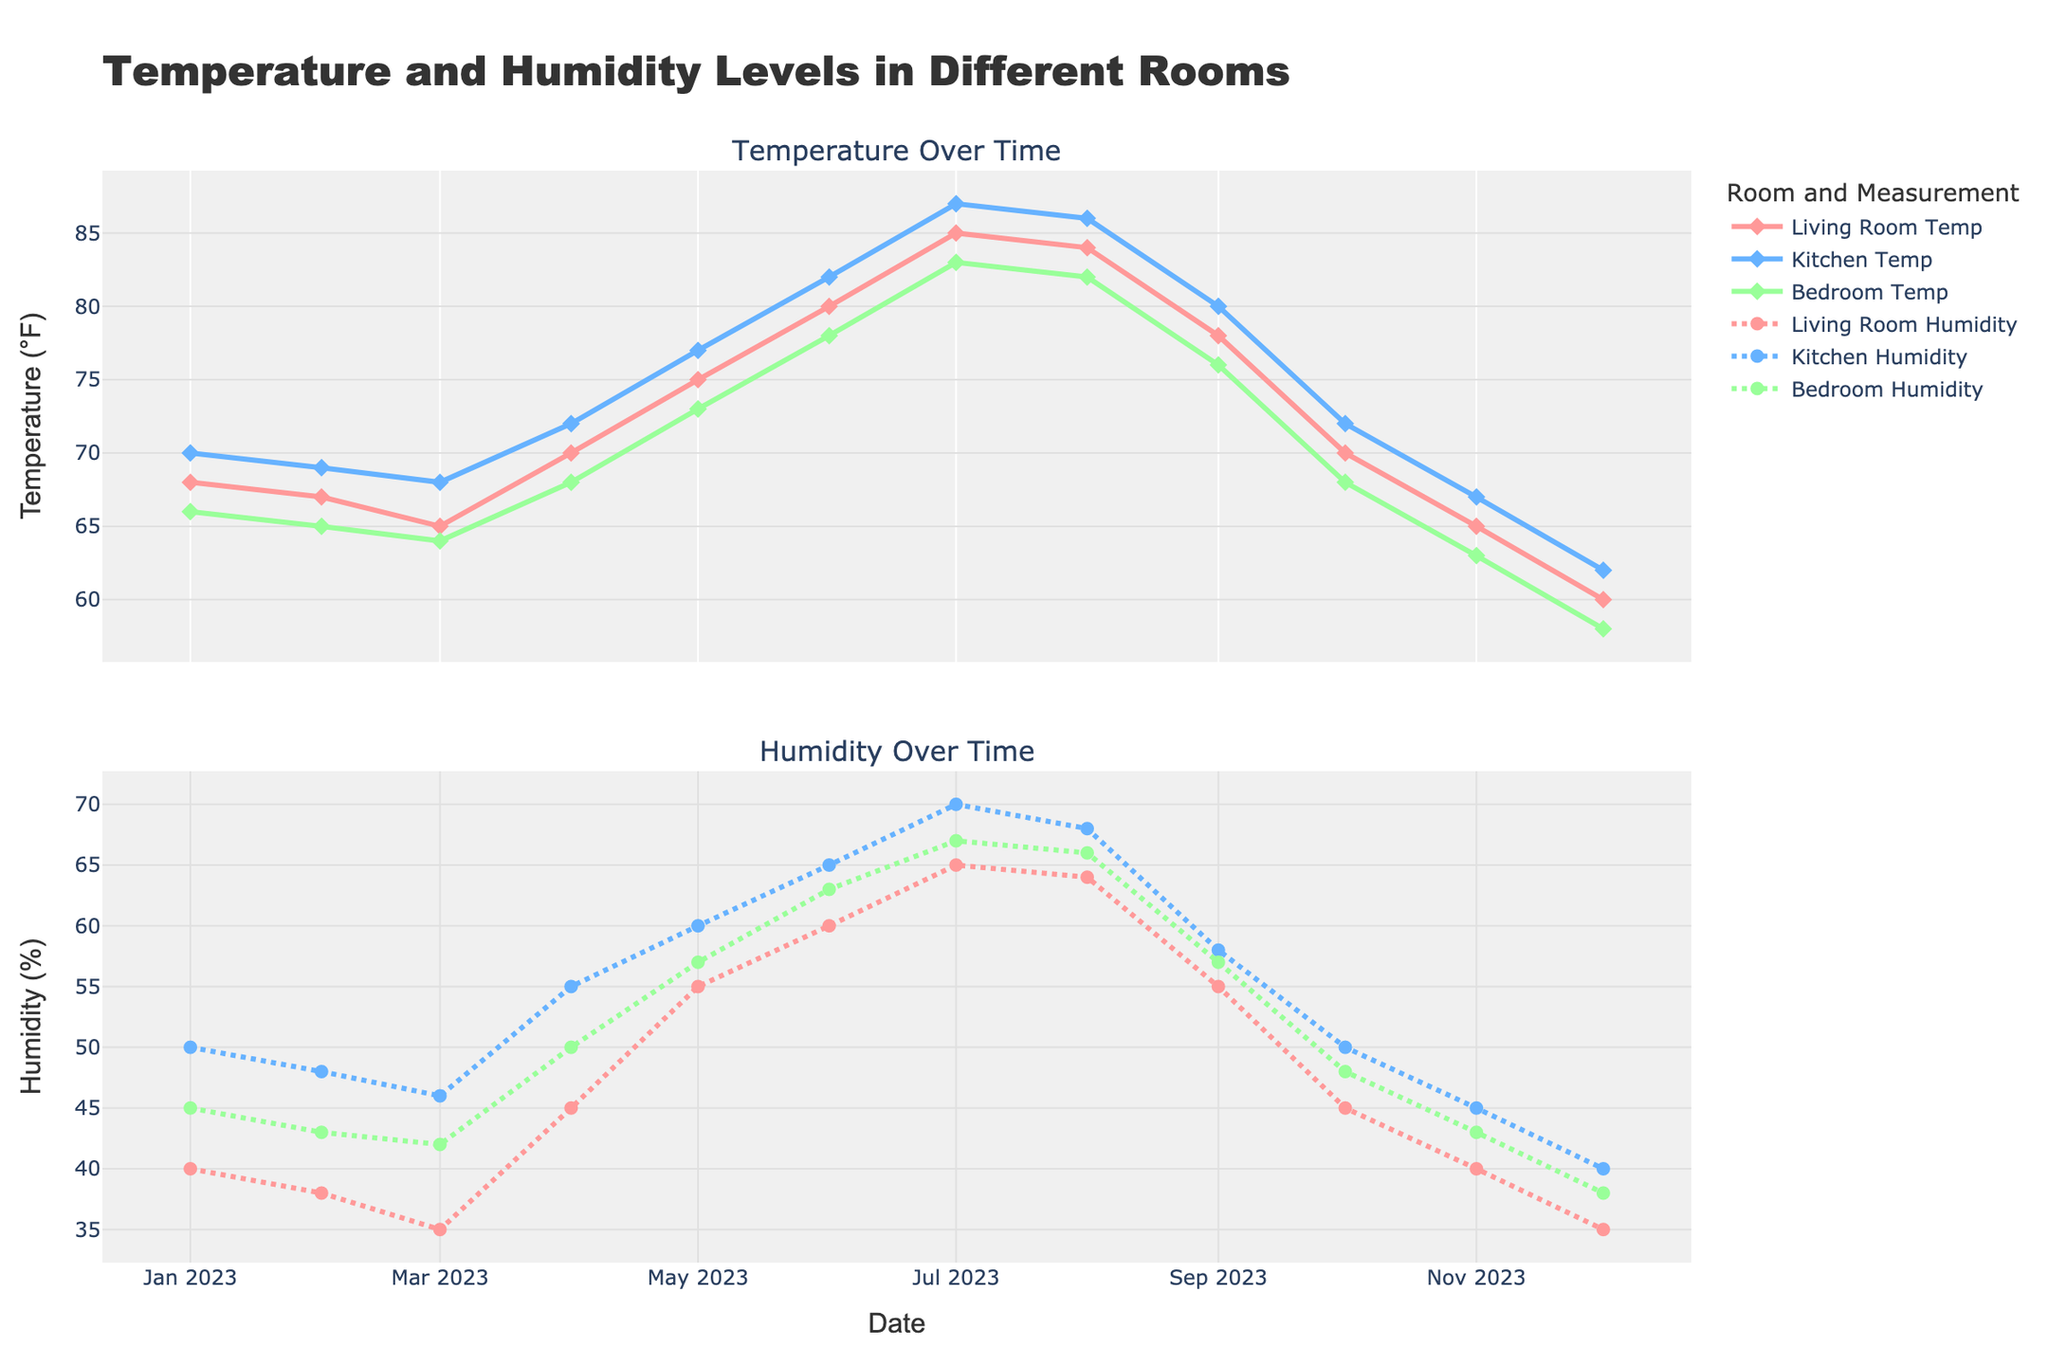What is the title of the figure? The title of the figure is generally displayed at the top of the visual information. From the layout description, the title is "Temperature and Humidity Levels in Different Rooms."
Answer: Temperature and Humidity Levels in Different Rooms Which room has the highest temperature in July? To find the highest temperature in July, locate the data points for July and compare the temperatures for the Living Room, Kitchen, and Bedroom. The Kitchen shows the highest temperature, which is 87°F.
Answer: Kitchen In which month does the Living Room have the lowest humidity and what is the value? Look at the humidity levels for the Living Room across all months. The lowest humidity is in December at 35%.
Answer: December, 35% Compare the temperature trends in the Living Room and the Bedroom. Which room shows a higher increase in temperature from January to July? Measure the increase in temperature from January (Living Room: 68°F, Bedroom: 66°F) to July (Living Room: 85°F, Bedroom: 83°F). Calculate the differences: 85 - 68 = 17°F for the Living Room and 83 - 66 = 17°F for the Bedroom. Both rooms show the same increase.
Answer: Both rooms show an equal increase What is the average humidity level in the Kitchen during the summer months (June, July, and August)? Identify the humidity levels in the Kitchen for June (65%), July (70%), and August (68%), then calculate the average: (65 + 70 + 68) / 3 = 67.67%.
Answer: 67.67% In which month is the temperature difference between the Living Room and the Bedroom the greatest, and what is this difference? Compare the temperature differences across all months. The largest difference is in January with Living Room (68°F) and Bedroom (66°F), leading to a 2°F difference.
Answer: January, 2°F How does the humidity in the Bedroom in April compare to that in November? Locate the humidity values for the Bedroom in April (50%) and November (43%). April has higher humidity compared to November.
Answer: April has higher humidity Which season shows the highest average temperature for the Living Room? To find the highest average seasonal temperature for the Living Room, calculate the averages for each season: Winter (68+67+65 / 3 = 66.67°F), Spring (70+75 / 2 = 72.5°F), Summer (80+85+84 / 3 = 83°F), Fall (78+70 / 2 = 74°F). The highest average is in Summer.
Answer: Summer What is the trend in humidity levels for the Kitchen from September to December? Observe the humidity levels for the Kitchen from September (58%), October (50%), November (45%), and December (40%). The trend shows a decreasing humidity level.
Answer: Decreasing What is the overall temperature range observed in the Kitchen throughout the year? Identify the highest temperature in the Kitchen (87°F in July) and the lowest temperature (62°F in December). Calculate the range: 87 - 62 = 25°F.
Answer: 25°F 